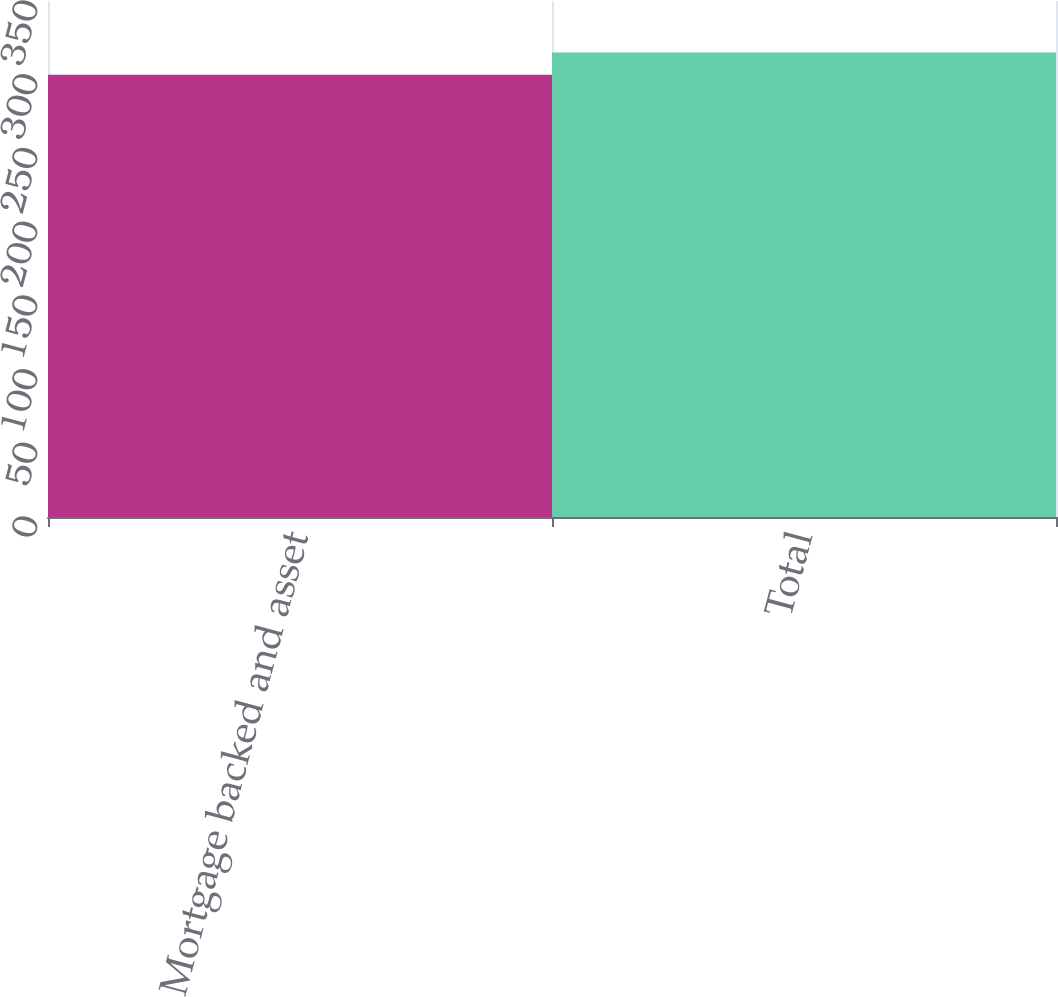Convert chart. <chart><loc_0><loc_0><loc_500><loc_500><bar_chart><fcel>Mortgage backed and asset<fcel>Total<nl><fcel>300<fcel>315<nl></chart> 